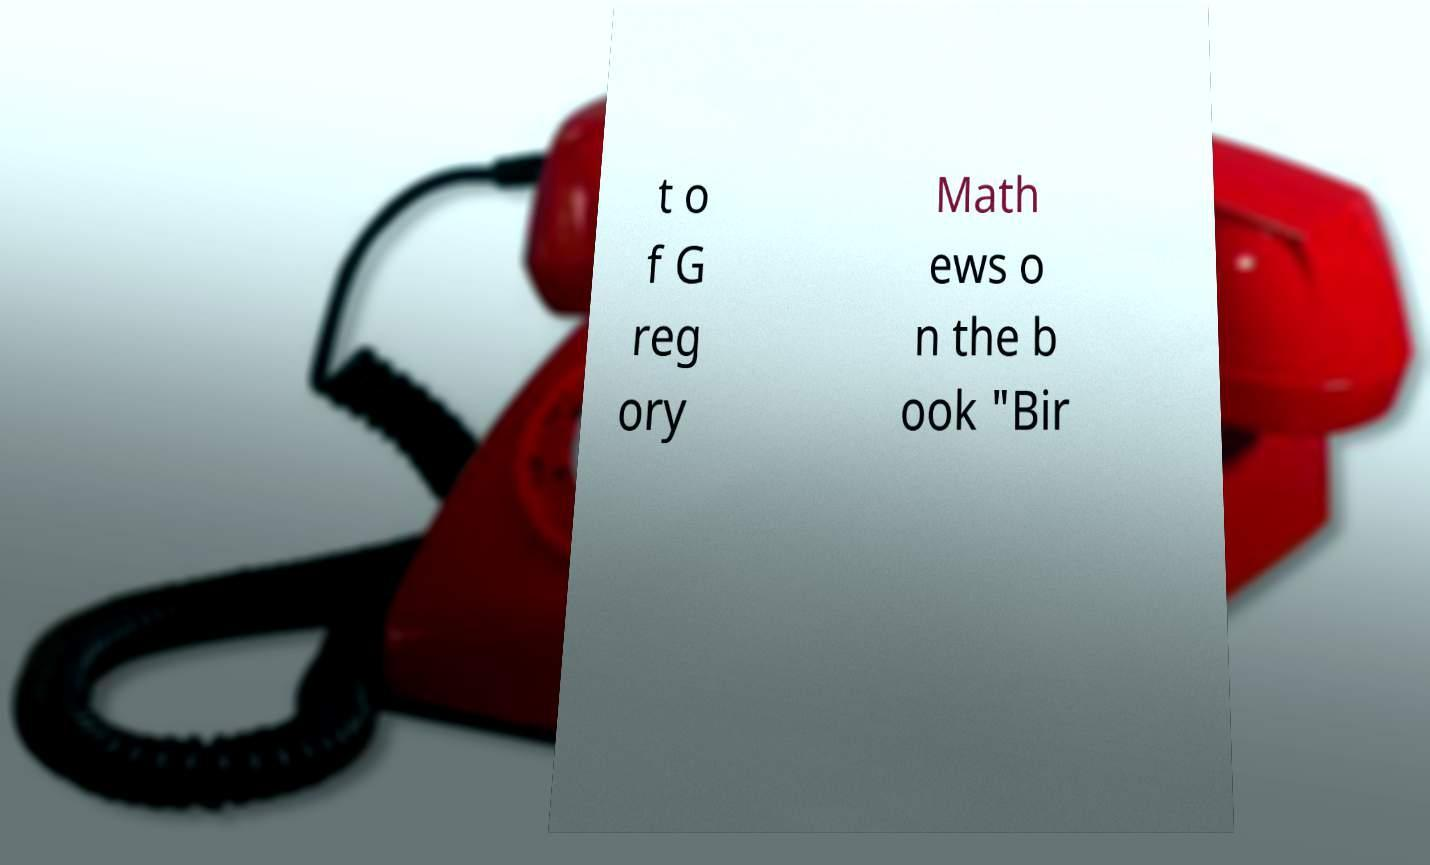I need the written content from this picture converted into text. Can you do that? t o f G reg ory Math ews o n the b ook "Bir 